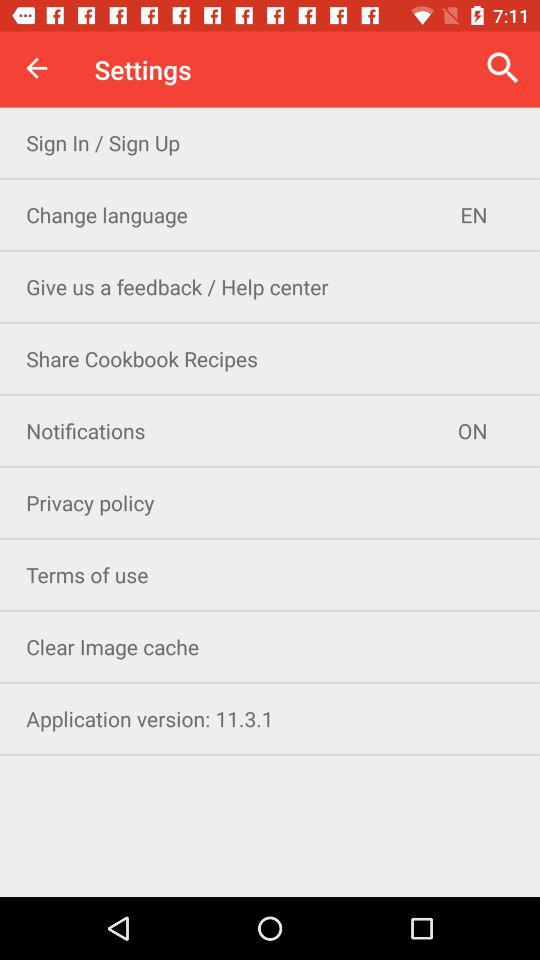What is the status of the notifications? The status is on. 